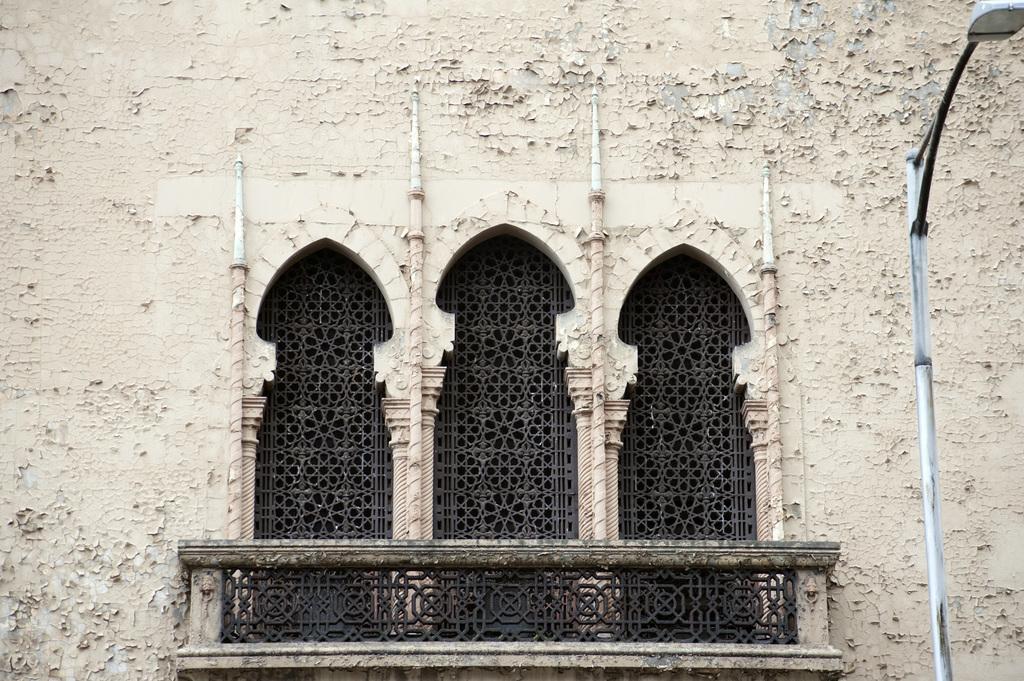Please provide a concise description of this image. In this picture, there is a castle with windows and hand-grill. Towards the right, there is a pole with light. 